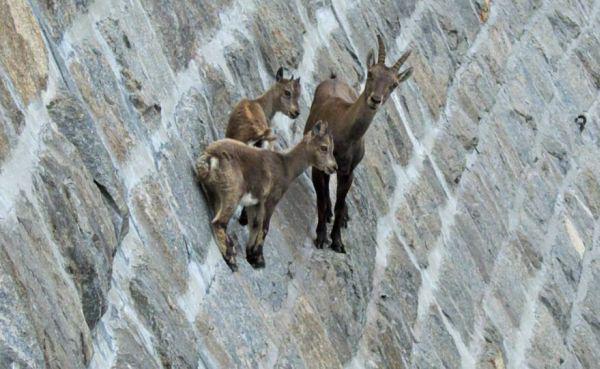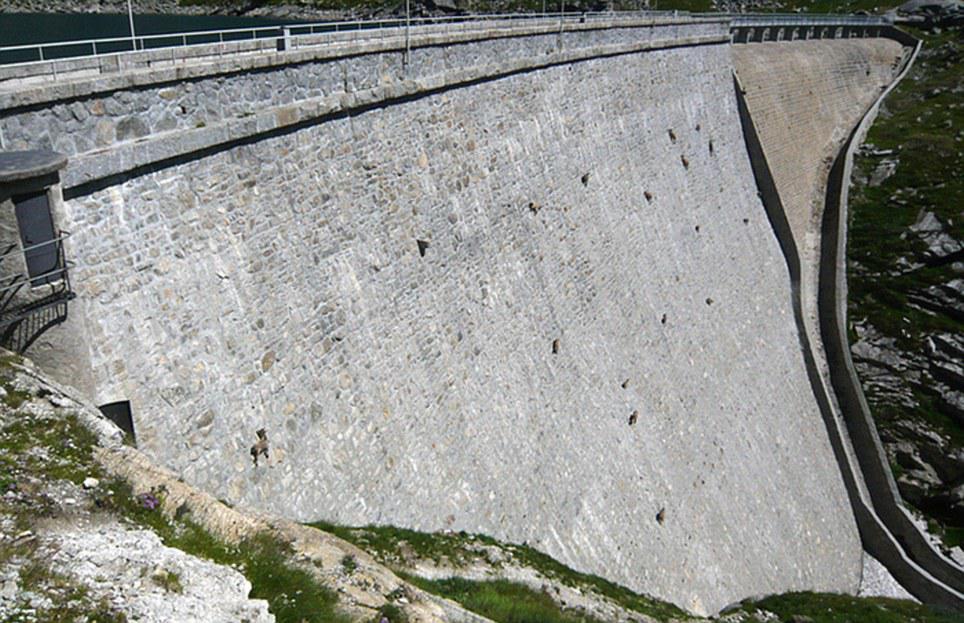The first image is the image on the left, the second image is the image on the right. Evaluate the accuracy of this statement regarding the images: "At least one image in each pair has exactly three animals together on a wall.". Is it true? Answer yes or no. Yes. 